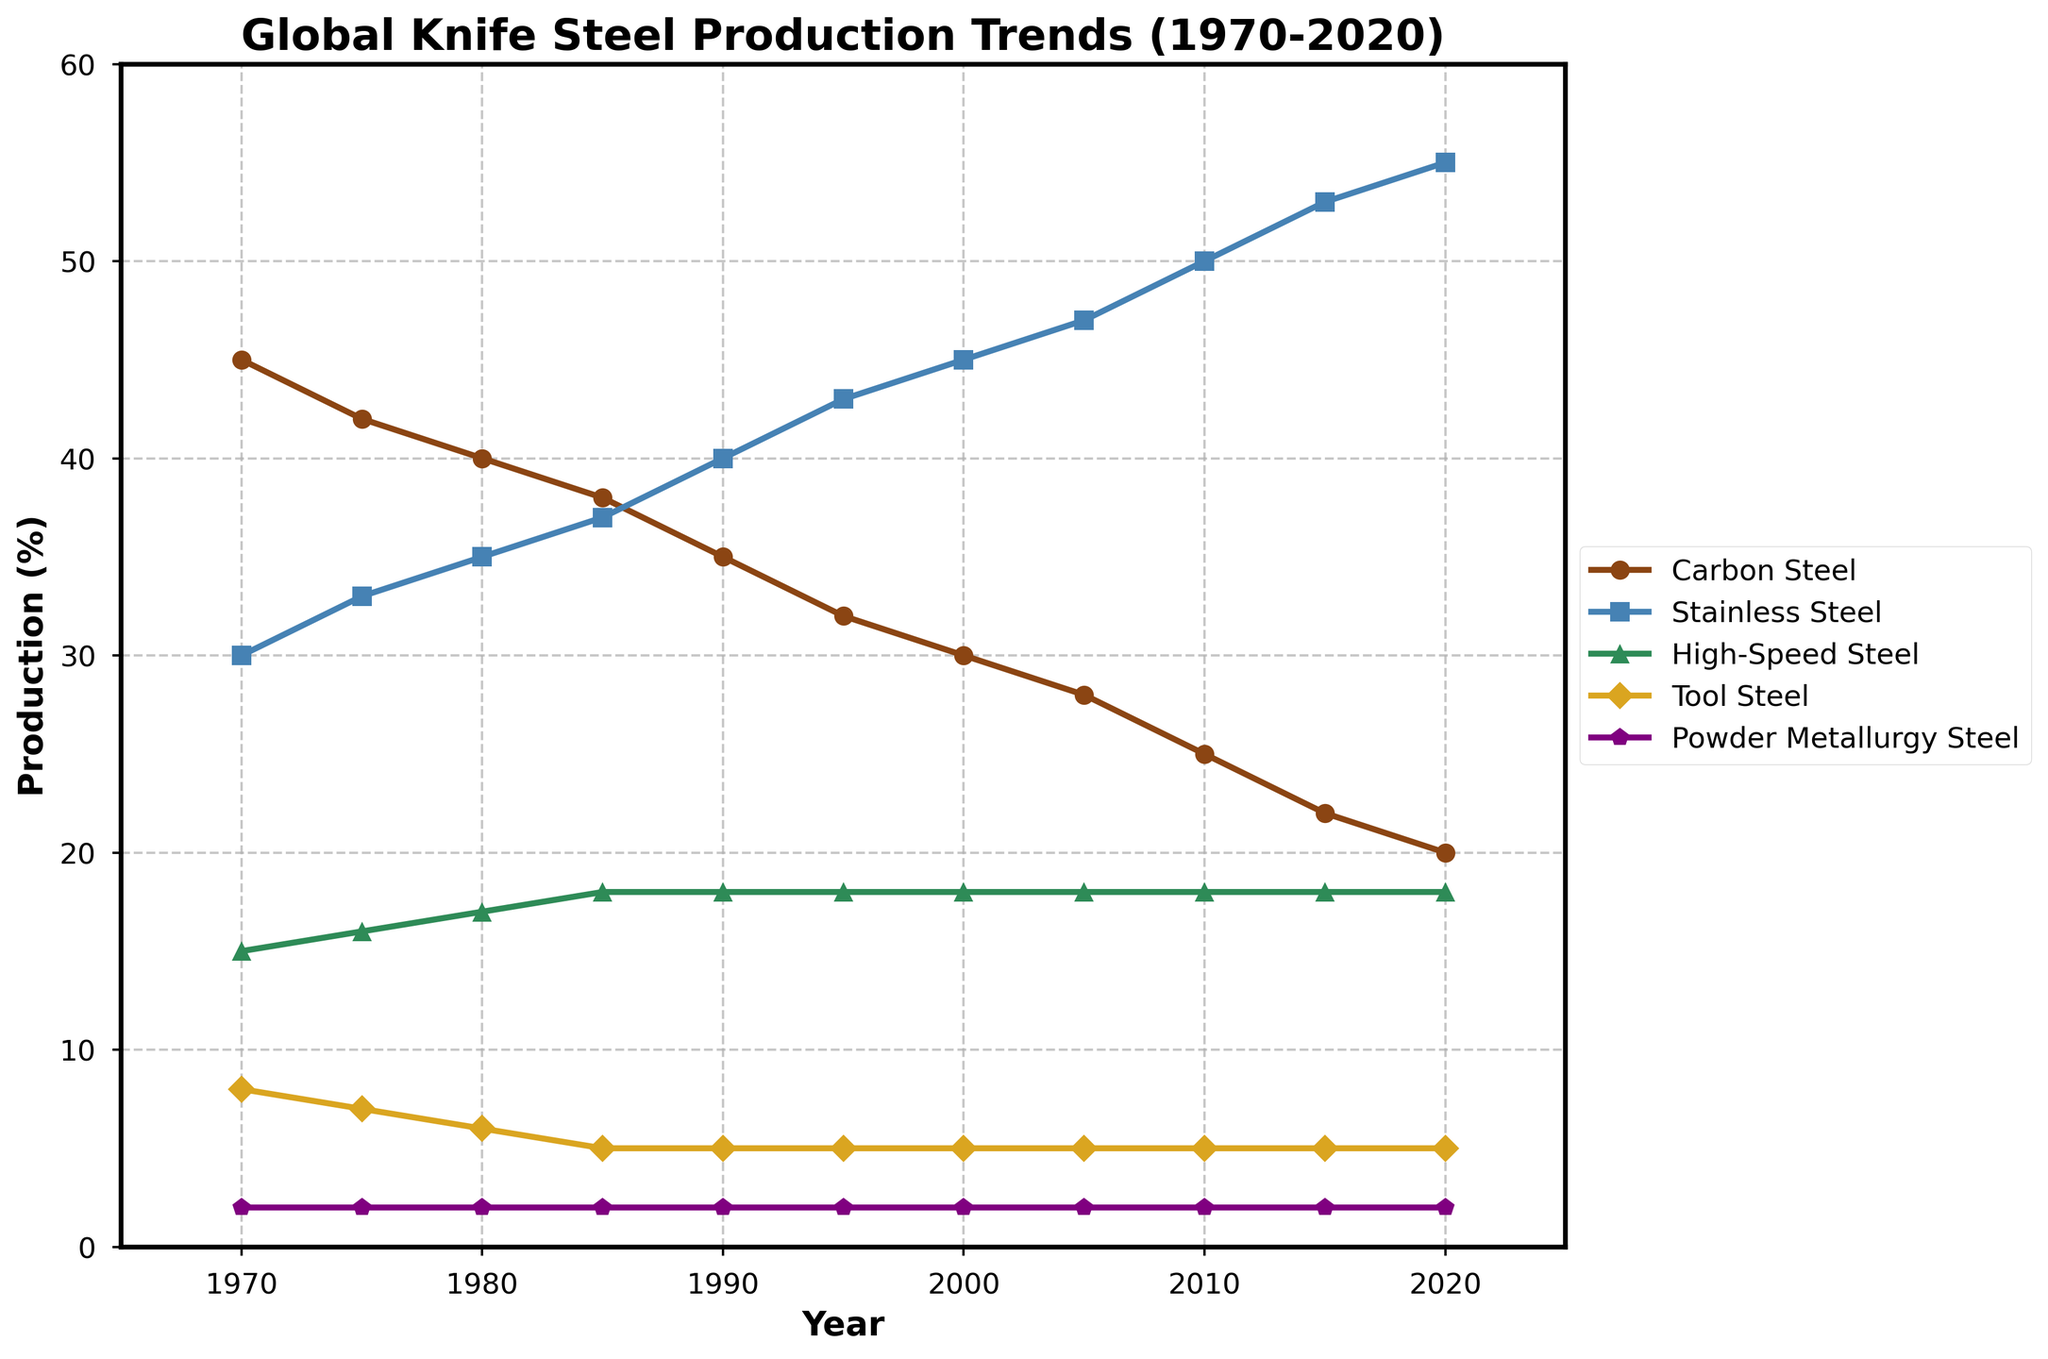What trend do you notice for Carbon Steel production from 1970 to 2020? Observing the line for Carbon Steel, the production percentage steadily decreases from 45% in 1970 to 20% in 2020
Answer: Decreasing trend Which steel type has the highest production percentage in 2020? By looking at the endpoint of each line in 2020, the line representing Stainless Steel reaches the highest point at 55%
Answer: Stainless Steel Between which two consecutive years did Carbon Steel production drop the most? By calculating the differences between consecutive years for Carbon Steel: 1970-1975: -3, 1975-1980: -2, 1980-1985: -2, 1985-1990: -3, 1990-1995: -3, 1995-2000: -2, 2000-2005: -2, 2005-2010: -3, 2010-2015: -3, 2015-2020: -2, the greatest drop is between 1970-1975
Answer: 1970 to 1975 How does the production of High-Speed Steel in 1970 compare to 2020? Checking the production percentages in 1970 and 2020 for High-Speed Steel, both values are 15% and 18% respectively, indicating a slight increase over 50 years
Answer: Slight increase Which steel type sees the least variation in production percentage over the 50 years span? Evaluating the range for each steel type: Carbon Steel (45-20=25), Stainless Steel (55-30=25), High-Speed Steel (18-15=3), Tool Steel (8-5=3), Powder Metallurgy Steel (2-2=0). The Powder Metallurgy Steel shows the least variation
Answer: Powder Metallurgy Steel Compare the production percentages of Tool Steel in 1970 and 1990. Which year had a higher production percentage and by how much? Tool Steel production is 8% in 1970 and 5% in 1990. Subtracting these gives 8%-5% = 3%, indicating higher production in 1970 by 3%
Answer: 1970, by 3% What is the total percentage of production occupied by Carbon Steel and Stainless Steel combined in 1985? Adding the percentages for Carbon Steel (38%) and Stainless Steel (37%) in 1985, we get 38% + 37% = 75%
Answer: 75% Which steel type's production line exhibits the most consistent increase throughout the years? Observing the slope consistency, the line representing Stainless Steel shows a consistent rising trend from 30% in 1970 to 55% in 2020
Answer: Stainless Steel What is the average production percentage for Tool Steel over the entire 50 years span? Summing up the Tool Steel production percentages: 8 + 7 + 6 + 5 + 5 + 5 + 5 + 5 + 5 + 5 + 5 = 61. Dividing by the number of years (11) gives 61/11 = 5.55%
Answer: 5.55% Which steel type had the largest decline in production from 1970 to 2020? Comparing the differences for each steel type: Carbon Steel (45-20=25), Stainless Steel (increase), High-Speed Steel (15-18=-3, increase), Tool Steel (8-5=3), Powder Metallurgy Steel (2-2=0), the largest decline is seen in Carbon Steel by 25%
Answer: Carbon Steel 